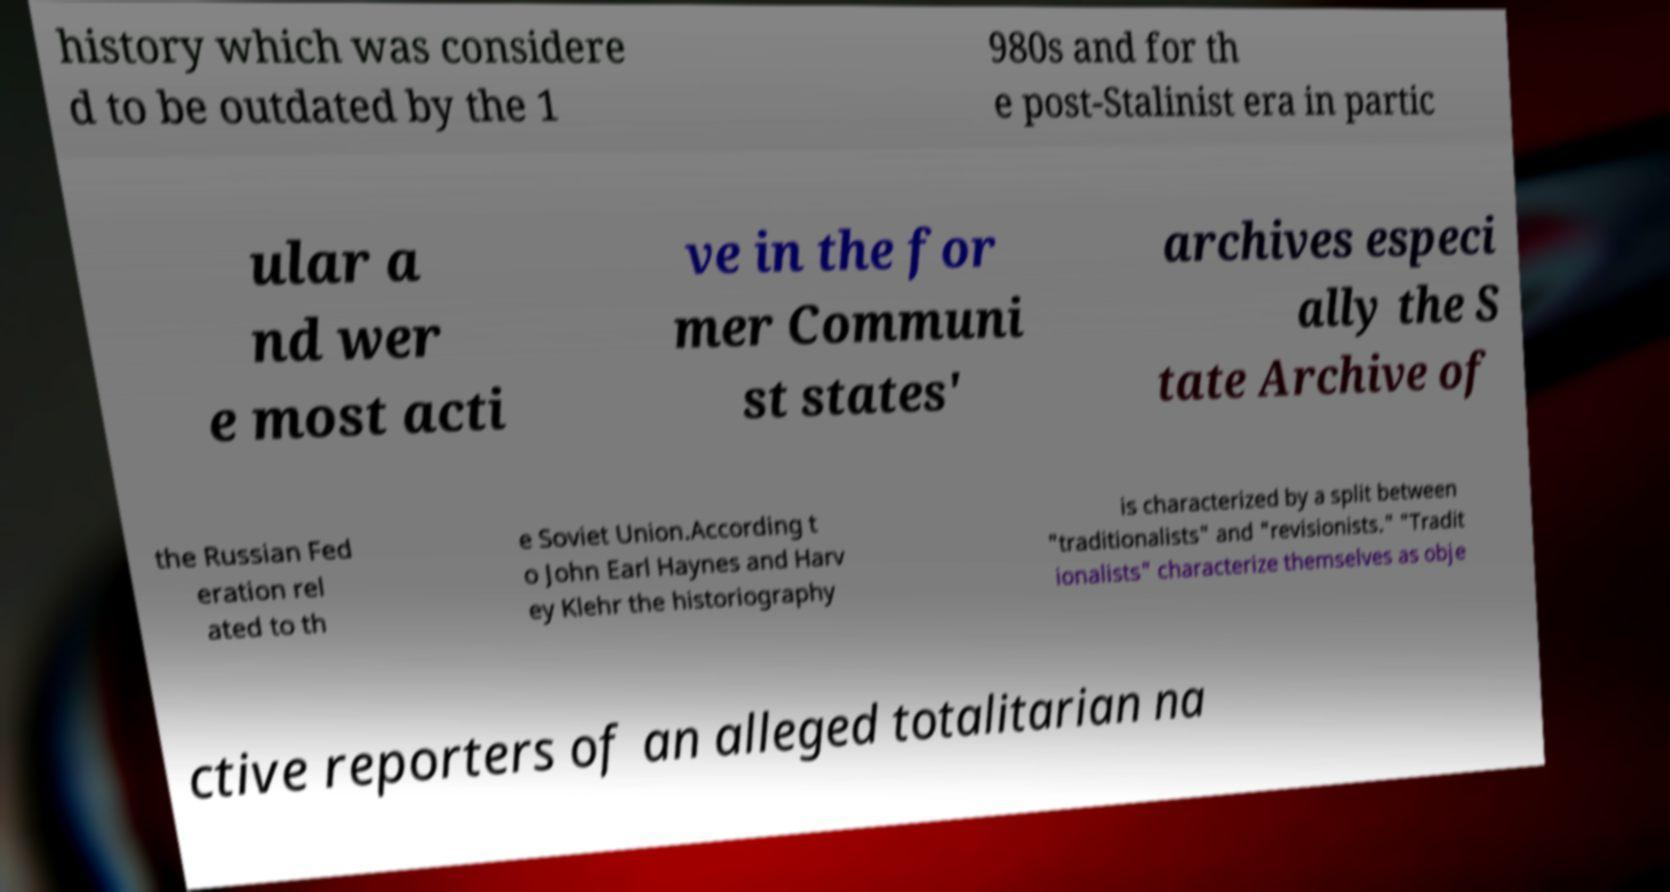Can you read and provide the text displayed in the image?This photo seems to have some interesting text. Can you extract and type it out for me? history which was considere d to be outdated by the 1 980s and for th e post-Stalinist era in partic ular a nd wer e most acti ve in the for mer Communi st states' archives especi ally the S tate Archive of the Russian Fed eration rel ated to th e Soviet Union.According t o John Earl Haynes and Harv ey Klehr the historiography is characterized by a split between "traditionalists" and "revisionists." "Tradit ionalists" characterize themselves as obje ctive reporters of an alleged totalitarian na 